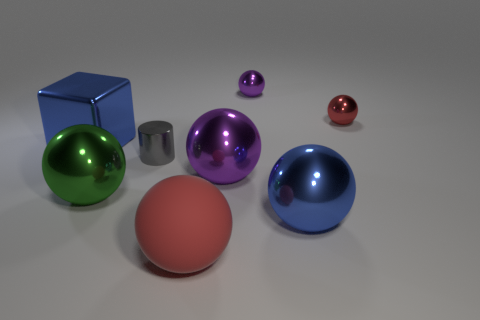How many tiny things are either matte objects or green shiny things?
Ensure brevity in your answer.  0. There is a green thing that is made of the same material as the cylinder; what shape is it?
Offer a very short reply. Sphere. Are there fewer big blue blocks that are behind the red shiny thing than purple metal things?
Keep it short and to the point. Yes. Do the red matte object and the tiny red thing have the same shape?
Ensure brevity in your answer.  Yes. What number of matte objects are blue blocks or blue things?
Ensure brevity in your answer.  0. Is there another gray thing that has the same size as the gray object?
Keep it short and to the point. No. There is a thing that is the same color as the block; what is its shape?
Ensure brevity in your answer.  Sphere. How many green things have the same size as the gray cylinder?
Ensure brevity in your answer.  0. Does the purple shiny sphere behind the tiny red object have the same size as the red thing behind the rubber sphere?
Make the answer very short. Yes. What number of things are large purple objects or large objects that are in front of the tiny gray metal object?
Your answer should be very brief. 4. 